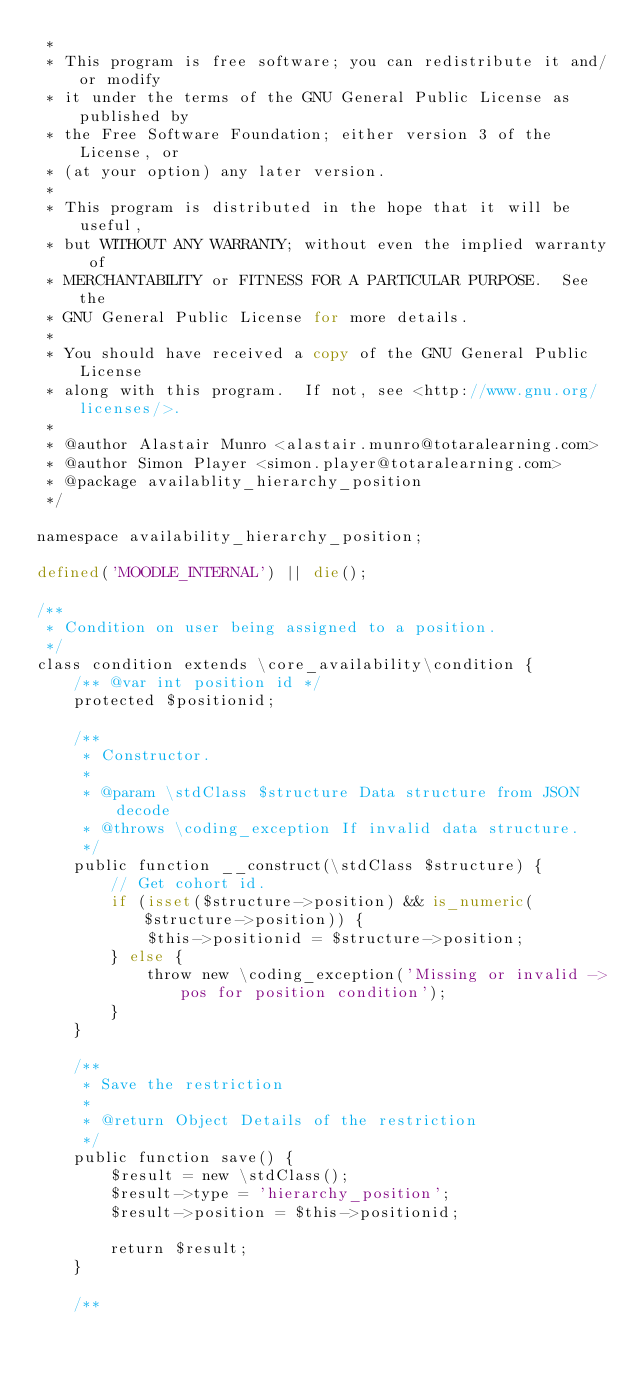<code> <loc_0><loc_0><loc_500><loc_500><_PHP_> *
 * This program is free software; you can redistribute it and/or modify
 * it under the terms of the GNU General Public License as published by
 * the Free Software Foundation; either version 3 of the License, or
 * (at your option) any later version.
 *
 * This program is distributed in the hope that it will be useful,
 * but WITHOUT ANY WARRANTY; without even the implied warranty of
 * MERCHANTABILITY or FITNESS FOR A PARTICULAR PURPOSE.  See the
 * GNU General Public License for more details.
 *
 * You should have received a copy of the GNU General Public License
 * along with this program.  If not, see <http://www.gnu.org/licenses/>.
 *
 * @author Alastair Munro <alastair.munro@totaralearning.com>
 * @author Simon Player <simon.player@totaralearning.com>
 * @package availablity_hierarchy_position
 */

namespace availability_hierarchy_position;

defined('MOODLE_INTERNAL') || die();

/**
 * Condition on user being assigned to a position.
 */
class condition extends \core_availability\condition {
    /** @var int position id */
    protected $positionid;

    /**
     * Constructor.
     *
     * @param \stdClass $structure Data structure from JSON decode
     * @throws \coding_exception If invalid data structure.
     */
    public function __construct(\stdClass $structure) {
        // Get cohort id.
        if (isset($structure->position) && is_numeric($structure->position)) {
            $this->positionid = $structure->position;
        } else {
            throw new \coding_exception('Missing or invalid ->pos for position condition');
        }
    }

    /**
     * Save the restriction
     *
     * @return Object Details of the restriction
     */
    public function save() {
        $result = new \stdClass();
        $result->type = 'hierarchy_position';
        $result->position = $this->positionid;

        return $result;
    }

    /**</code> 